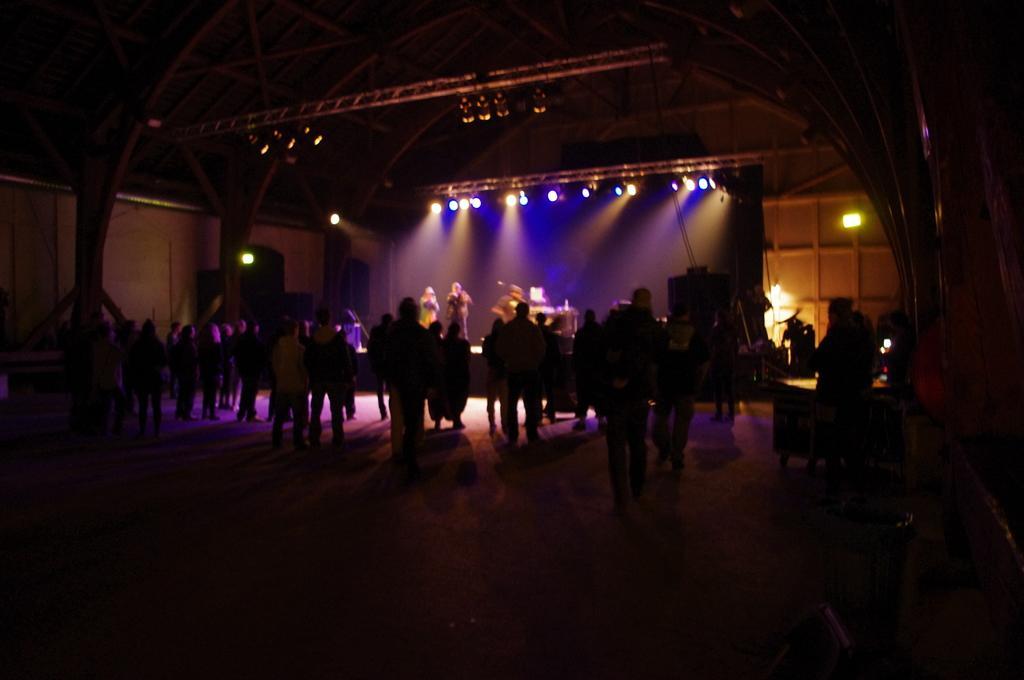Please provide a concise description of this image. In this picture we can see a group of people on the ground and in the background we can see the wall, lights, roof and some objects. 